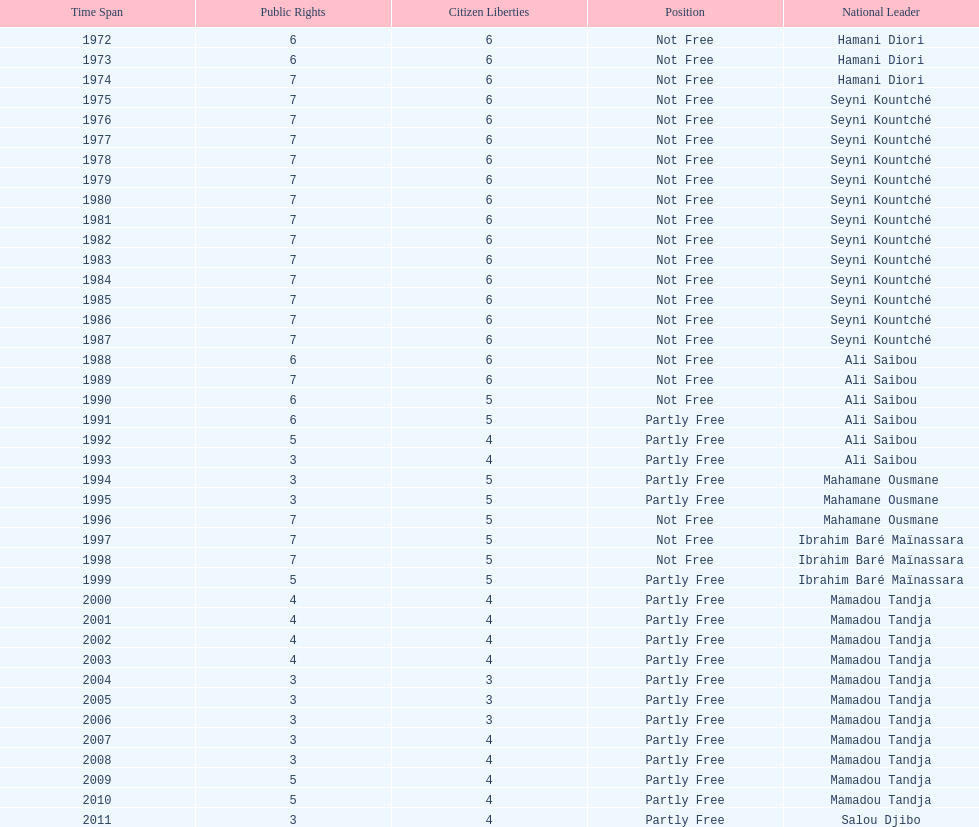What was the duration of ali saibou's presidency? 6. 